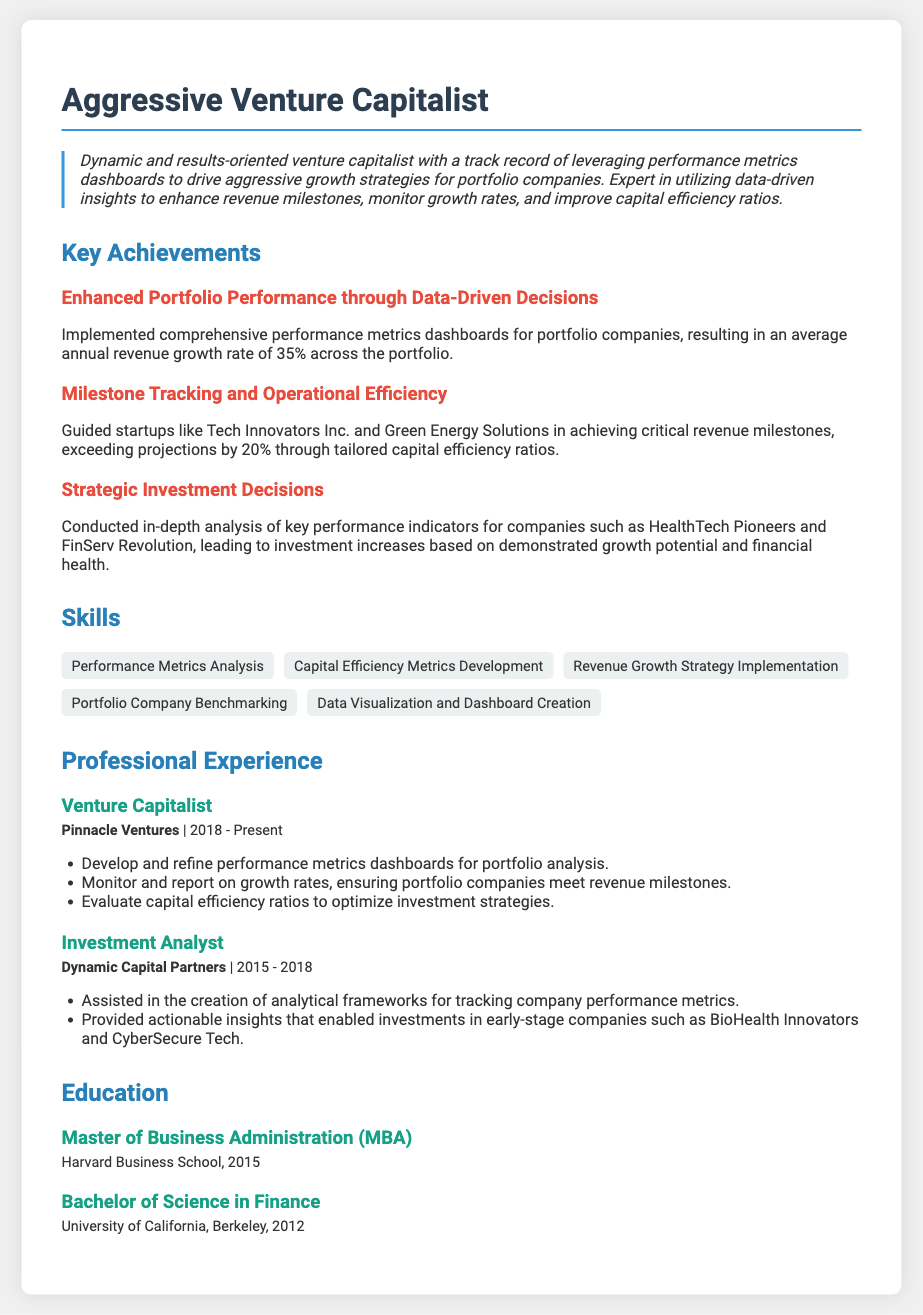what is the average annual revenue growth rate across the portfolio? The document states that the average annual revenue growth rate is 35%.
Answer: 35% which company is mentioned as having exceeded revenue projections by 20%? The document specifically mentions Green Energy Solutions.
Answer: Green Energy Solutions how many years has the individual worked at Pinnacle Ventures? The document indicates the individual has worked at Pinnacle Ventures since 2018 and the current year is assumed to be 2023, which totals to 5 years.
Answer: 5 years what degree was obtained from Harvard Business School? The document specifies that a Master of Business Administration (MBA) was obtained.
Answer: Master of Business Administration (MBA) which skill involves creating performance metrics dashboards? The skill related to creating performance metrics dashboards is "Data Visualization and Dashboard Creation."
Answer: Data Visualization and Dashboard Creation what was the individual's role at Dynamic Capital Partners? The document identifies the role as Investment Analyst.
Answer: Investment Analyst how much did the company exceed revenue milestones by? The document states critical revenue milestones were exceeded by 20%.
Answer: 20% name one of the portfolio companies mentioned in relation to strategic investment decisions. The document mentions HealthTech Pioneers as one of the companies.
Answer: HealthTech Pioneers 